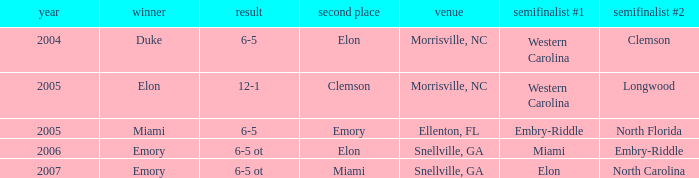List the scores of all games when Miami were listed as the first Semi finalist 6-5 ot. Can you parse all the data within this table? {'header': ['year', 'winner', 'result', 'second place', 'venue', 'semifinalist #1', 'semifinalist #2'], 'rows': [['2004', 'Duke', '6-5', 'Elon', 'Morrisville, NC', 'Western Carolina', 'Clemson'], ['2005', 'Elon', '12-1', 'Clemson', 'Morrisville, NC', 'Western Carolina', 'Longwood'], ['2005', 'Miami', '6-5', 'Emory', 'Ellenton, FL', 'Embry-Riddle', 'North Florida'], ['2006', 'Emory', '6-5 ot', 'Elon', 'Snellville, GA', 'Miami', 'Embry-Riddle'], ['2007', 'Emory', '6-5 ot', 'Miami', 'Snellville, GA', 'Elon', 'North Carolina']]} 